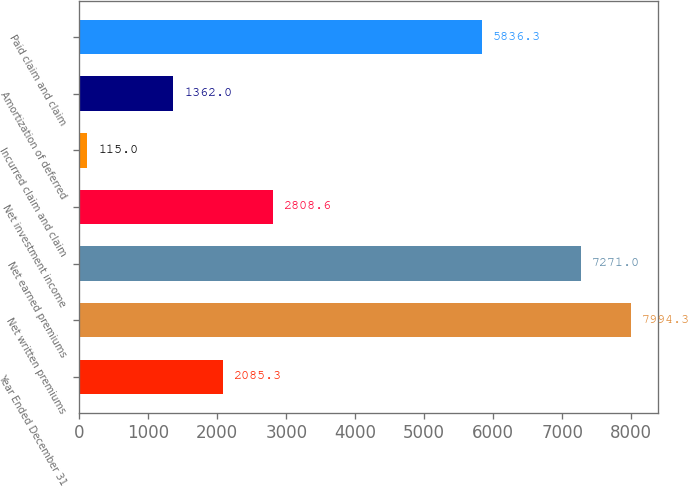<chart> <loc_0><loc_0><loc_500><loc_500><bar_chart><fcel>Year Ended December 31<fcel>Net written premiums<fcel>Net earned premiums<fcel>Net investment income<fcel>Incurred claim and claim<fcel>Amortization of deferred<fcel>Paid claim and claim<nl><fcel>2085.3<fcel>7994.3<fcel>7271<fcel>2808.6<fcel>115<fcel>1362<fcel>5836.3<nl></chart> 